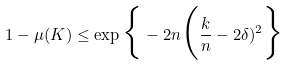<formula> <loc_0><loc_0><loc_500><loc_500>1 - \mu ( K ) \leq \exp \Big \{ - 2 n \Big ( \frac { k } n - 2 \delta ) ^ { 2 } \Big \}</formula> 